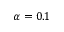<formula> <loc_0><loc_0><loc_500><loc_500>\alpha = 0 . 1</formula> 